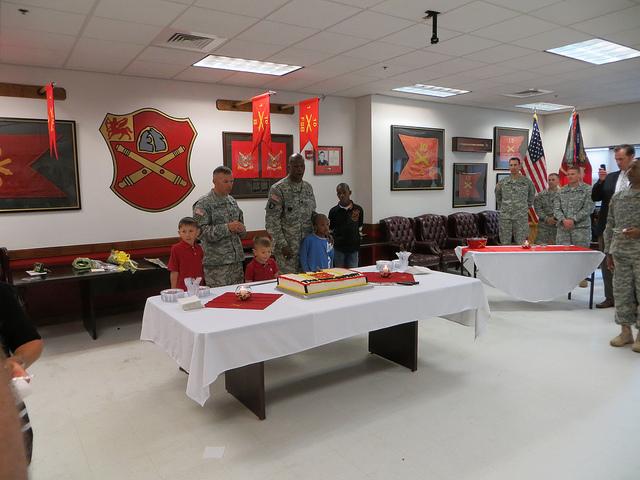Is the American flag in the photo?
Short answer required. Yes. How many people are in the room?
Keep it brief. 13. Does this look like a military event?
Short answer required. Yes. Are these soldiers in dress uniforms?
Be succinct. Yes. What is the bottom of the building made of?
Short answer required. Concrete. What is the floor made of?
Quick response, please. Tile. What kind of room is this?
Answer briefly. Banquet. 